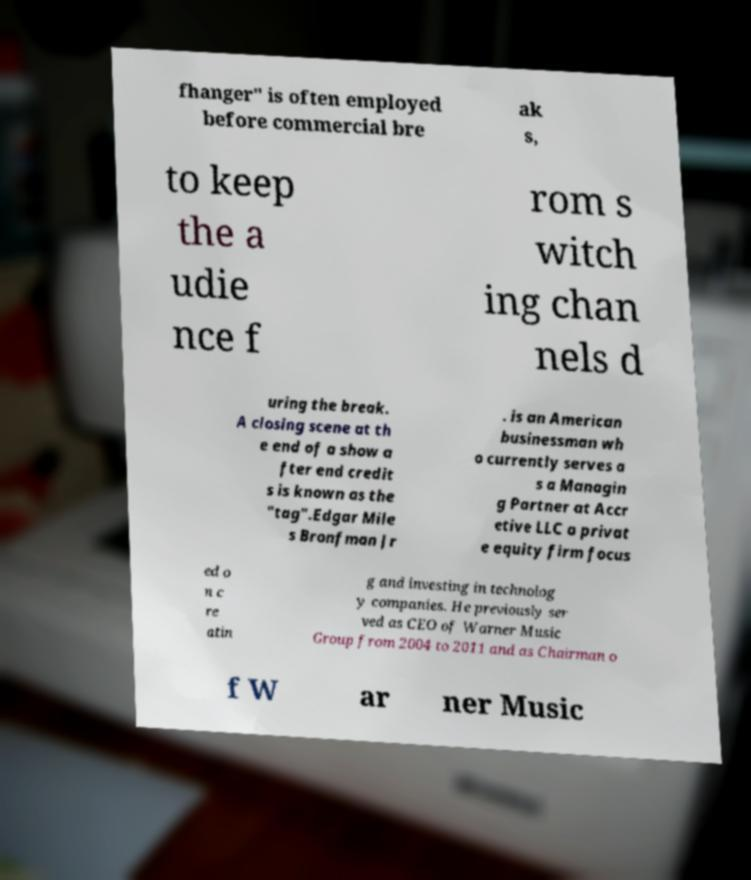What messages or text are displayed in this image? I need them in a readable, typed format. fhanger" is often employed before commercial bre ak s, to keep the a udie nce f rom s witch ing chan nels d uring the break. A closing scene at th e end of a show a fter end credit s is known as the "tag".Edgar Mile s Bronfman Jr . is an American businessman wh o currently serves a s a Managin g Partner at Accr etive LLC a privat e equity firm focus ed o n c re atin g and investing in technolog y companies. He previously ser ved as CEO of Warner Music Group from 2004 to 2011 and as Chairman o f W ar ner Music 